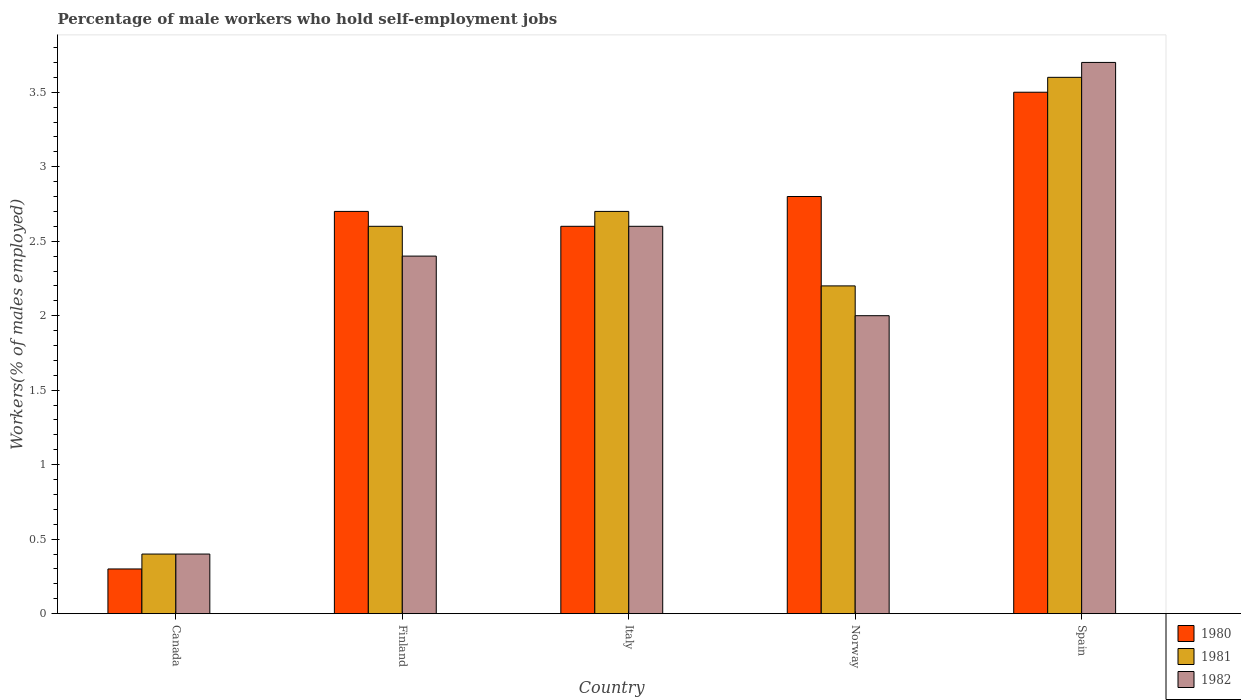How many different coloured bars are there?
Keep it short and to the point. 3. How many bars are there on the 5th tick from the left?
Make the answer very short. 3. How many bars are there on the 5th tick from the right?
Provide a short and direct response. 3. What is the label of the 4th group of bars from the left?
Ensure brevity in your answer.  Norway. In how many cases, is the number of bars for a given country not equal to the number of legend labels?
Provide a succinct answer. 0. What is the percentage of self-employed male workers in 1981 in Norway?
Offer a terse response. 2.2. Across all countries, what is the minimum percentage of self-employed male workers in 1982?
Offer a very short reply. 0.4. What is the total percentage of self-employed male workers in 1982 in the graph?
Ensure brevity in your answer.  11.1. What is the difference between the percentage of self-employed male workers in 1982 in Canada and that in Spain?
Offer a very short reply. -3.3. What is the average percentage of self-employed male workers in 1981 per country?
Offer a very short reply. 2.3. What is the difference between the percentage of self-employed male workers of/in 1982 and percentage of self-employed male workers of/in 1980 in Norway?
Give a very brief answer. -0.8. In how many countries, is the percentage of self-employed male workers in 1980 greater than 1.8 %?
Provide a succinct answer. 4. What is the ratio of the percentage of self-employed male workers in 1981 in Norway to that in Spain?
Provide a succinct answer. 0.61. Is the percentage of self-employed male workers in 1980 in Finland less than that in Norway?
Your answer should be compact. Yes. Is the difference between the percentage of self-employed male workers in 1982 in Canada and Finland greater than the difference between the percentage of self-employed male workers in 1980 in Canada and Finland?
Offer a very short reply. Yes. What is the difference between the highest and the second highest percentage of self-employed male workers in 1980?
Provide a succinct answer. -0.1. What is the difference between the highest and the lowest percentage of self-employed male workers in 1982?
Give a very brief answer. 3.3. What does the 3rd bar from the left in Norway represents?
Keep it short and to the point. 1982. What does the 2nd bar from the right in Italy represents?
Keep it short and to the point. 1981. Is it the case that in every country, the sum of the percentage of self-employed male workers in 1981 and percentage of self-employed male workers in 1982 is greater than the percentage of self-employed male workers in 1980?
Your response must be concise. Yes. How many bars are there?
Offer a terse response. 15. What is the difference between two consecutive major ticks on the Y-axis?
Offer a very short reply. 0.5. Does the graph contain any zero values?
Offer a terse response. No. Does the graph contain grids?
Provide a short and direct response. No. Where does the legend appear in the graph?
Your answer should be compact. Bottom right. How are the legend labels stacked?
Offer a very short reply. Vertical. What is the title of the graph?
Your response must be concise. Percentage of male workers who hold self-employment jobs. What is the label or title of the Y-axis?
Your answer should be compact. Workers(% of males employed). What is the Workers(% of males employed) of 1980 in Canada?
Keep it short and to the point. 0.3. What is the Workers(% of males employed) of 1981 in Canada?
Offer a very short reply. 0.4. What is the Workers(% of males employed) in 1982 in Canada?
Your answer should be compact. 0.4. What is the Workers(% of males employed) of 1980 in Finland?
Give a very brief answer. 2.7. What is the Workers(% of males employed) of 1981 in Finland?
Keep it short and to the point. 2.6. What is the Workers(% of males employed) in 1982 in Finland?
Offer a very short reply. 2.4. What is the Workers(% of males employed) of 1980 in Italy?
Offer a very short reply. 2.6. What is the Workers(% of males employed) of 1981 in Italy?
Your response must be concise. 2.7. What is the Workers(% of males employed) of 1982 in Italy?
Ensure brevity in your answer.  2.6. What is the Workers(% of males employed) of 1980 in Norway?
Offer a terse response. 2.8. What is the Workers(% of males employed) in 1981 in Norway?
Your answer should be compact. 2.2. What is the Workers(% of males employed) of 1982 in Norway?
Your response must be concise. 2. What is the Workers(% of males employed) in 1980 in Spain?
Offer a terse response. 3.5. What is the Workers(% of males employed) in 1981 in Spain?
Your answer should be very brief. 3.6. What is the Workers(% of males employed) of 1982 in Spain?
Your response must be concise. 3.7. Across all countries, what is the maximum Workers(% of males employed) in 1981?
Make the answer very short. 3.6. Across all countries, what is the maximum Workers(% of males employed) of 1982?
Ensure brevity in your answer.  3.7. Across all countries, what is the minimum Workers(% of males employed) in 1980?
Give a very brief answer. 0.3. Across all countries, what is the minimum Workers(% of males employed) in 1981?
Give a very brief answer. 0.4. Across all countries, what is the minimum Workers(% of males employed) in 1982?
Keep it short and to the point. 0.4. What is the difference between the Workers(% of males employed) in 1980 in Canada and that in Finland?
Ensure brevity in your answer.  -2.4. What is the difference between the Workers(% of males employed) in 1981 in Canada and that in Finland?
Provide a succinct answer. -2.2. What is the difference between the Workers(% of males employed) of 1981 in Canada and that in Italy?
Your answer should be very brief. -2.3. What is the difference between the Workers(% of males employed) of 1982 in Canada and that in Italy?
Give a very brief answer. -2.2. What is the difference between the Workers(% of males employed) in 1980 in Canada and that in Norway?
Keep it short and to the point. -2.5. What is the difference between the Workers(% of males employed) in 1981 in Canada and that in Norway?
Keep it short and to the point. -1.8. What is the difference between the Workers(% of males employed) in 1982 in Canada and that in Norway?
Give a very brief answer. -1.6. What is the difference between the Workers(% of males employed) in 1980 in Canada and that in Spain?
Your response must be concise. -3.2. What is the difference between the Workers(% of males employed) in 1981 in Canada and that in Spain?
Provide a succinct answer. -3.2. What is the difference between the Workers(% of males employed) in 1980 in Finland and that in Spain?
Offer a very short reply. -0.8. What is the difference between the Workers(% of males employed) in 1982 in Finland and that in Spain?
Make the answer very short. -1.3. What is the difference between the Workers(% of males employed) in 1982 in Italy and that in Norway?
Your answer should be very brief. 0.6. What is the difference between the Workers(% of males employed) in 1980 in Italy and that in Spain?
Ensure brevity in your answer.  -0.9. What is the difference between the Workers(% of males employed) in 1981 in Italy and that in Spain?
Provide a succinct answer. -0.9. What is the difference between the Workers(% of males employed) in 1980 in Norway and that in Spain?
Your answer should be very brief. -0.7. What is the difference between the Workers(% of males employed) in 1982 in Norway and that in Spain?
Your response must be concise. -1.7. What is the difference between the Workers(% of males employed) of 1981 in Canada and the Workers(% of males employed) of 1982 in Italy?
Make the answer very short. -2.2. What is the difference between the Workers(% of males employed) of 1981 in Canada and the Workers(% of males employed) of 1982 in Norway?
Ensure brevity in your answer.  -1.6. What is the difference between the Workers(% of males employed) in 1980 in Canada and the Workers(% of males employed) in 1982 in Spain?
Provide a succinct answer. -3.4. What is the difference between the Workers(% of males employed) in 1981 in Finland and the Workers(% of males employed) in 1982 in Italy?
Make the answer very short. 0. What is the difference between the Workers(% of males employed) of 1980 in Finland and the Workers(% of males employed) of 1981 in Norway?
Your response must be concise. 0.5. What is the difference between the Workers(% of males employed) in 1980 in Finland and the Workers(% of males employed) in 1982 in Norway?
Give a very brief answer. 0.7. What is the difference between the Workers(% of males employed) in 1980 in Finland and the Workers(% of males employed) in 1982 in Spain?
Your answer should be compact. -1. What is the difference between the Workers(% of males employed) in 1980 in Italy and the Workers(% of males employed) in 1981 in Norway?
Provide a succinct answer. 0.4. What is the difference between the Workers(% of males employed) in 1980 in Italy and the Workers(% of males employed) in 1981 in Spain?
Keep it short and to the point. -1. What is the average Workers(% of males employed) in 1980 per country?
Give a very brief answer. 2.38. What is the average Workers(% of males employed) in 1982 per country?
Keep it short and to the point. 2.22. What is the difference between the Workers(% of males employed) in 1980 and Workers(% of males employed) in 1982 in Canada?
Ensure brevity in your answer.  -0.1. What is the difference between the Workers(% of males employed) in 1981 and Workers(% of males employed) in 1982 in Canada?
Provide a succinct answer. 0. What is the difference between the Workers(% of males employed) of 1980 and Workers(% of males employed) of 1982 in Finland?
Your answer should be very brief. 0.3. What is the difference between the Workers(% of males employed) of 1981 and Workers(% of males employed) of 1982 in Finland?
Offer a terse response. 0.2. What is the difference between the Workers(% of males employed) in 1980 and Workers(% of males employed) in 1981 in Italy?
Provide a short and direct response. -0.1. What is the difference between the Workers(% of males employed) in 1980 and Workers(% of males employed) in 1981 in Spain?
Offer a terse response. -0.1. What is the difference between the Workers(% of males employed) of 1980 and Workers(% of males employed) of 1982 in Spain?
Your answer should be very brief. -0.2. What is the difference between the Workers(% of males employed) in 1981 and Workers(% of males employed) in 1982 in Spain?
Keep it short and to the point. -0.1. What is the ratio of the Workers(% of males employed) of 1980 in Canada to that in Finland?
Give a very brief answer. 0.11. What is the ratio of the Workers(% of males employed) of 1981 in Canada to that in Finland?
Offer a very short reply. 0.15. What is the ratio of the Workers(% of males employed) in 1982 in Canada to that in Finland?
Make the answer very short. 0.17. What is the ratio of the Workers(% of males employed) of 1980 in Canada to that in Italy?
Give a very brief answer. 0.12. What is the ratio of the Workers(% of males employed) in 1981 in Canada to that in Italy?
Give a very brief answer. 0.15. What is the ratio of the Workers(% of males employed) of 1982 in Canada to that in Italy?
Ensure brevity in your answer.  0.15. What is the ratio of the Workers(% of males employed) in 1980 in Canada to that in Norway?
Keep it short and to the point. 0.11. What is the ratio of the Workers(% of males employed) in 1981 in Canada to that in Norway?
Provide a short and direct response. 0.18. What is the ratio of the Workers(% of males employed) of 1980 in Canada to that in Spain?
Keep it short and to the point. 0.09. What is the ratio of the Workers(% of males employed) of 1981 in Canada to that in Spain?
Give a very brief answer. 0.11. What is the ratio of the Workers(% of males employed) of 1982 in Canada to that in Spain?
Your response must be concise. 0.11. What is the ratio of the Workers(% of males employed) in 1982 in Finland to that in Italy?
Provide a short and direct response. 0.92. What is the ratio of the Workers(% of males employed) in 1981 in Finland to that in Norway?
Make the answer very short. 1.18. What is the ratio of the Workers(% of males employed) of 1982 in Finland to that in Norway?
Ensure brevity in your answer.  1.2. What is the ratio of the Workers(% of males employed) of 1980 in Finland to that in Spain?
Provide a short and direct response. 0.77. What is the ratio of the Workers(% of males employed) of 1981 in Finland to that in Spain?
Provide a succinct answer. 0.72. What is the ratio of the Workers(% of males employed) in 1982 in Finland to that in Spain?
Keep it short and to the point. 0.65. What is the ratio of the Workers(% of males employed) of 1980 in Italy to that in Norway?
Offer a terse response. 0.93. What is the ratio of the Workers(% of males employed) in 1981 in Italy to that in Norway?
Keep it short and to the point. 1.23. What is the ratio of the Workers(% of males employed) in 1982 in Italy to that in Norway?
Make the answer very short. 1.3. What is the ratio of the Workers(% of males employed) in 1980 in Italy to that in Spain?
Your answer should be compact. 0.74. What is the ratio of the Workers(% of males employed) in 1982 in Italy to that in Spain?
Give a very brief answer. 0.7. What is the ratio of the Workers(% of males employed) of 1981 in Norway to that in Spain?
Your response must be concise. 0.61. What is the ratio of the Workers(% of males employed) of 1982 in Norway to that in Spain?
Provide a short and direct response. 0.54. What is the difference between the highest and the second highest Workers(% of males employed) in 1980?
Your answer should be very brief. 0.7. What is the difference between the highest and the second highest Workers(% of males employed) of 1981?
Make the answer very short. 0.9. What is the difference between the highest and the lowest Workers(% of males employed) in 1980?
Keep it short and to the point. 3.2. What is the difference between the highest and the lowest Workers(% of males employed) of 1981?
Provide a succinct answer. 3.2. 